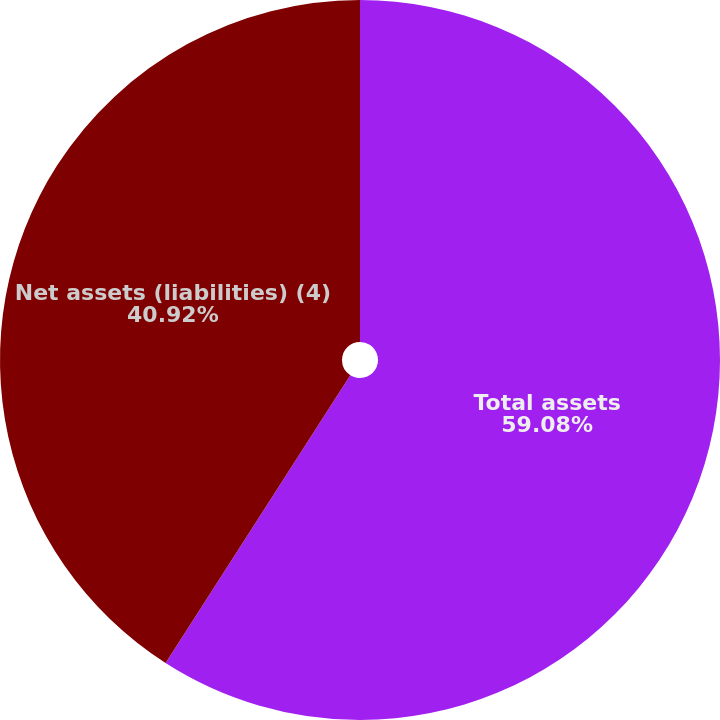Convert chart. <chart><loc_0><loc_0><loc_500><loc_500><pie_chart><fcel>Total assets<fcel>Net assets (liabilities) (4)<nl><fcel>59.08%<fcel>40.92%<nl></chart> 